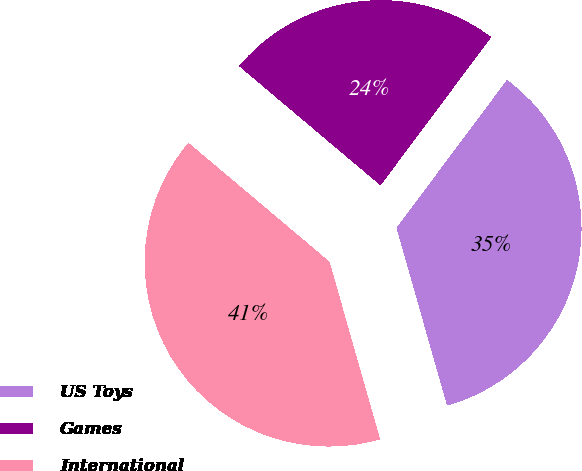Convert chart to OTSL. <chart><loc_0><loc_0><loc_500><loc_500><pie_chart><fcel>US Toys<fcel>Games<fcel>International<nl><fcel>35.38%<fcel>24.06%<fcel>40.56%<nl></chart> 